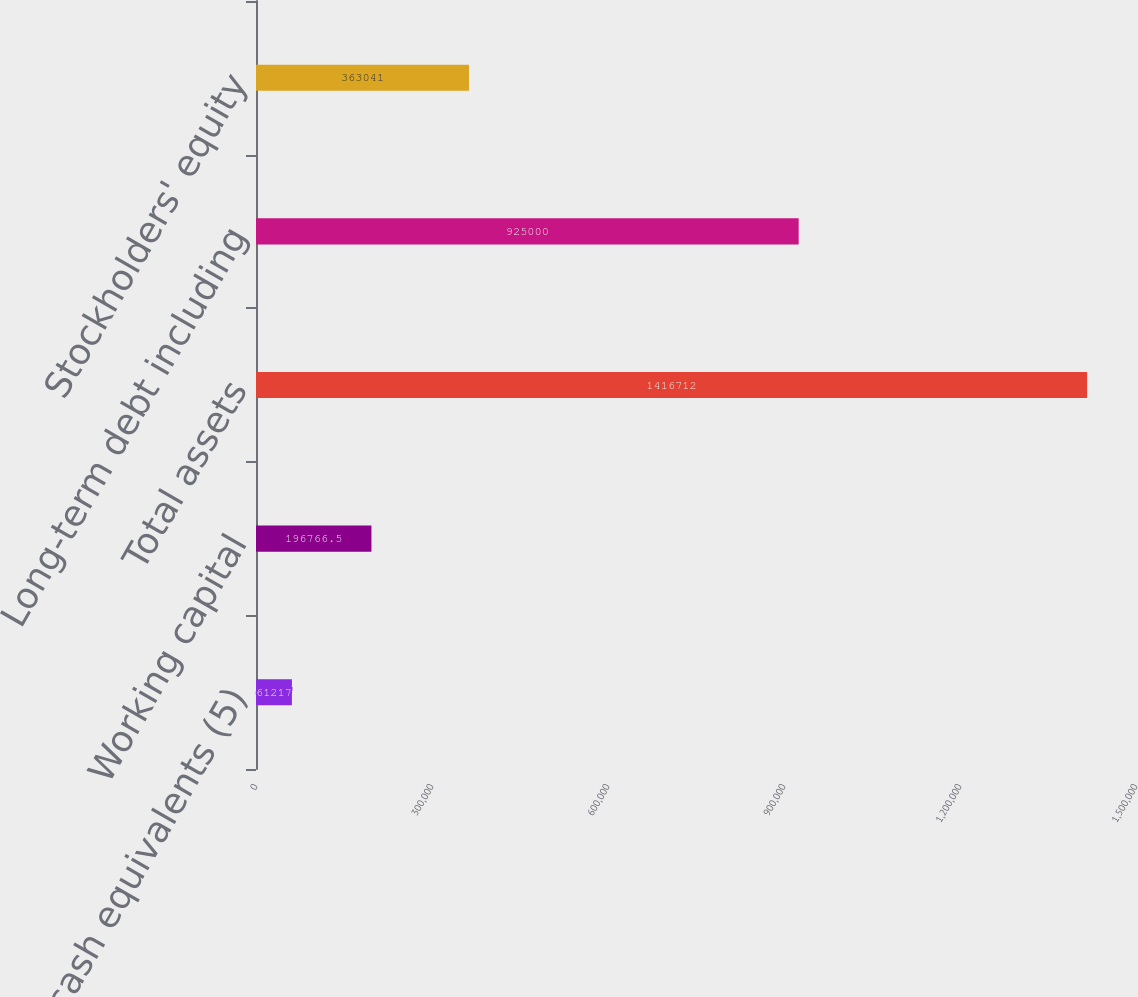<chart> <loc_0><loc_0><loc_500><loc_500><bar_chart><fcel>Cash and cash equivalents (5)<fcel>Working capital<fcel>Total assets<fcel>Long-term debt including<fcel>Stockholders' equity<nl><fcel>61217<fcel>196766<fcel>1.41671e+06<fcel>925000<fcel>363041<nl></chart> 